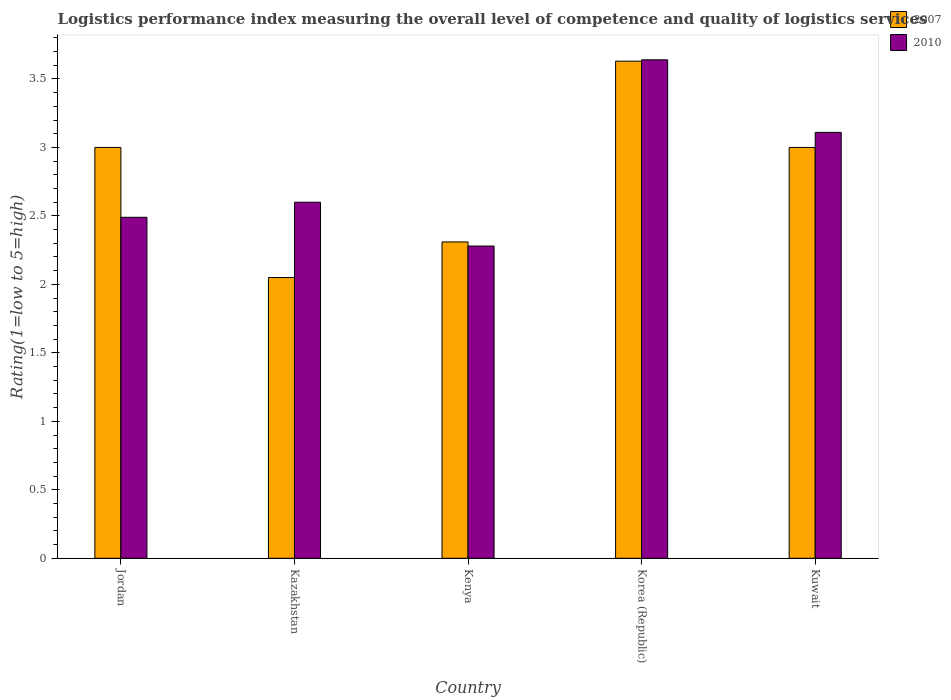How many groups of bars are there?
Make the answer very short. 5. How many bars are there on the 3rd tick from the right?
Keep it short and to the point. 2. What is the label of the 2nd group of bars from the left?
Make the answer very short. Kazakhstan. In how many cases, is the number of bars for a given country not equal to the number of legend labels?
Keep it short and to the point. 0. What is the Logistic performance index in 2010 in Kenya?
Your answer should be compact. 2.28. Across all countries, what is the maximum Logistic performance index in 2007?
Provide a succinct answer. 3.63. Across all countries, what is the minimum Logistic performance index in 2010?
Provide a short and direct response. 2.28. In which country was the Logistic performance index in 2010 minimum?
Ensure brevity in your answer.  Kenya. What is the total Logistic performance index in 2010 in the graph?
Your response must be concise. 14.12. What is the difference between the Logistic performance index in 2010 in Jordan and that in Korea (Republic)?
Your answer should be compact. -1.15. What is the difference between the Logistic performance index in 2007 in Korea (Republic) and the Logistic performance index in 2010 in Kenya?
Your response must be concise. 1.35. What is the average Logistic performance index in 2007 per country?
Your response must be concise. 2.8. What is the difference between the Logistic performance index of/in 2007 and Logistic performance index of/in 2010 in Kenya?
Your answer should be compact. 0.03. What is the ratio of the Logistic performance index in 2007 in Jordan to that in Kazakhstan?
Offer a terse response. 1.46. Is the difference between the Logistic performance index in 2007 in Korea (Republic) and Kuwait greater than the difference between the Logistic performance index in 2010 in Korea (Republic) and Kuwait?
Your response must be concise. Yes. What is the difference between the highest and the second highest Logistic performance index in 2007?
Provide a short and direct response. -0.63. What is the difference between the highest and the lowest Logistic performance index in 2007?
Ensure brevity in your answer.  1.58. Is the sum of the Logistic performance index in 2007 in Kazakhstan and Kuwait greater than the maximum Logistic performance index in 2010 across all countries?
Ensure brevity in your answer.  Yes. What does the 1st bar from the right in Kuwait represents?
Your response must be concise. 2010. How many bars are there?
Make the answer very short. 10. How many countries are there in the graph?
Provide a succinct answer. 5. Does the graph contain any zero values?
Give a very brief answer. No. Does the graph contain grids?
Your answer should be compact. No. Where does the legend appear in the graph?
Provide a short and direct response. Top right. How many legend labels are there?
Ensure brevity in your answer.  2. What is the title of the graph?
Keep it short and to the point. Logistics performance index measuring the overall level of competence and quality of logistics services. What is the label or title of the Y-axis?
Give a very brief answer. Rating(1=low to 5=high). What is the Rating(1=low to 5=high) of 2010 in Jordan?
Your response must be concise. 2.49. What is the Rating(1=low to 5=high) of 2007 in Kazakhstan?
Offer a very short reply. 2.05. What is the Rating(1=low to 5=high) in 2010 in Kazakhstan?
Keep it short and to the point. 2.6. What is the Rating(1=low to 5=high) in 2007 in Kenya?
Provide a short and direct response. 2.31. What is the Rating(1=low to 5=high) in 2010 in Kenya?
Keep it short and to the point. 2.28. What is the Rating(1=low to 5=high) of 2007 in Korea (Republic)?
Ensure brevity in your answer.  3.63. What is the Rating(1=low to 5=high) of 2010 in Korea (Republic)?
Offer a terse response. 3.64. What is the Rating(1=low to 5=high) of 2010 in Kuwait?
Give a very brief answer. 3.11. Across all countries, what is the maximum Rating(1=low to 5=high) in 2007?
Provide a short and direct response. 3.63. Across all countries, what is the maximum Rating(1=low to 5=high) of 2010?
Provide a short and direct response. 3.64. Across all countries, what is the minimum Rating(1=low to 5=high) in 2007?
Ensure brevity in your answer.  2.05. Across all countries, what is the minimum Rating(1=low to 5=high) in 2010?
Your answer should be very brief. 2.28. What is the total Rating(1=low to 5=high) in 2007 in the graph?
Ensure brevity in your answer.  13.99. What is the total Rating(1=low to 5=high) of 2010 in the graph?
Your answer should be compact. 14.12. What is the difference between the Rating(1=low to 5=high) of 2010 in Jordan and that in Kazakhstan?
Keep it short and to the point. -0.11. What is the difference between the Rating(1=low to 5=high) of 2007 in Jordan and that in Kenya?
Offer a very short reply. 0.69. What is the difference between the Rating(1=low to 5=high) in 2010 in Jordan and that in Kenya?
Offer a very short reply. 0.21. What is the difference between the Rating(1=low to 5=high) in 2007 in Jordan and that in Korea (Republic)?
Offer a very short reply. -0.63. What is the difference between the Rating(1=low to 5=high) in 2010 in Jordan and that in Korea (Republic)?
Your answer should be very brief. -1.15. What is the difference between the Rating(1=low to 5=high) of 2007 in Jordan and that in Kuwait?
Make the answer very short. 0. What is the difference between the Rating(1=low to 5=high) of 2010 in Jordan and that in Kuwait?
Your answer should be very brief. -0.62. What is the difference between the Rating(1=low to 5=high) in 2007 in Kazakhstan and that in Kenya?
Make the answer very short. -0.26. What is the difference between the Rating(1=low to 5=high) of 2010 in Kazakhstan and that in Kenya?
Provide a short and direct response. 0.32. What is the difference between the Rating(1=low to 5=high) in 2007 in Kazakhstan and that in Korea (Republic)?
Your response must be concise. -1.58. What is the difference between the Rating(1=low to 5=high) of 2010 in Kazakhstan and that in Korea (Republic)?
Make the answer very short. -1.04. What is the difference between the Rating(1=low to 5=high) of 2007 in Kazakhstan and that in Kuwait?
Your answer should be compact. -0.95. What is the difference between the Rating(1=low to 5=high) of 2010 in Kazakhstan and that in Kuwait?
Keep it short and to the point. -0.51. What is the difference between the Rating(1=low to 5=high) in 2007 in Kenya and that in Korea (Republic)?
Your answer should be very brief. -1.32. What is the difference between the Rating(1=low to 5=high) in 2010 in Kenya and that in Korea (Republic)?
Your answer should be very brief. -1.36. What is the difference between the Rating(1=low to 5=high) in 2007 in Kenya and that in Kuwait?
Keep it short and to the point. -0.69. What is the difference between the Rating(1=low to 5=high) in 2010 in Kenya and that in Kuwait?
Your answer should be very brief. -0.83. What is the difference between the Rating(1=low to 5=high) of 2007 in Korea (Republic) and that in Kuwait?
Ensure brevity in your answer.  0.63. What is the difference between the Rating(1=low to 5=high) in 2010 in Korea (Republic) and that in Kuwait?
Your answer should be compact. 0.53. What is the difference between the Rating(1=low to 5=high) of 2007 in Jordan and the Rating(1=low to 5=high) of 2010 in Kazakhstan?
Give a very brief answer. 0.4. What is the difference between the Rating(1=low to 5=high) in 2007 in Jordan and the Rating(1=low to 5=high) in 2010 in Kenya?
Provide a succinct answer. 0.72. What is the difference between the Rating(1=low to 5=high) in 2007 in Jordan and the Rating(1=low to 5=high) in 2010 in Korea (Republic)?
Your answer should be compact. -0.64. What is the difference between the Rating(1=low to 5=high) in 2007 in Jordan and the Rating(1=low to 5=high) in 2010 in Kuwait?
Provide a succinct answer. -0.11. What is the difference between the Rating(1=low to 5=high) in 2007 in Kazakhstan and the Rating(1=low to 5=high) in 2010 in Kenya?
Keep it short and to the point. -0.23. What is the difference between the Rating(1=low to 5=high) of 2007 in Kazakhstan and the Rating(1=low to 5=high) of 2010 in Korea (Republic)?
Make the answer very short. -1.59. What is the difference between the Rating(1=low to 5=high) of 2007 in Kazakhstan and the Rating(1=low to 5=high) of 2010 in Kuwait?
Ensure brevity in your answer.  -1.06. What is the difference between the Rating(1=low to 5=high) of 2007 in Kenya and the Rating(1=low to 5=high) of 2010 in Korea (Republic)?
Offer a terse response. -1.33. What is the difference between the Rating(1=low to 5=high) of 2007 in Korea (Republic) and the Rating(1=low to 5=high) of 2010 in Kuwait?
Your answer should be compact. 0.52. What is the average Rating(1=low to 5=high) in 2007 per country?
Make the answer very short. 2.8. What is the average Rating(1=low to 5=high) of 2010 per country?
Provide a short and direct response. 2.82. What is the difference between the Rating(1=low to 5=high) in 2007 and Rating(1=low to 5=high) in 2010 in Jordan?
Provide a succinct answer. 0.51. What is the difference between the Rating(1=low to 5=high) in 2007 and Rating(1=low to 5=high) in 2010 in Kazakhstan?
Ensure brevity in your answer.  -0.55. What is the difference between the Rating(1=low to 5=high) in 2007 and Rating(1=low to 5=high) in 2010 in Kenya?
Your answer should be very brief. 0.03. What is the difference between the Rating(1=low to 5=high) in 2007 and Rating(1=low to 5=high) in 2010 in Korea (Republic)?
Provide a short and direct response. -0.01. What is the difference between the Rating(1=low to 5=high) of 2007 and Rating(1=low to 5=high) of 2010 in Kuwait?
Your answer should be compact. -0.11. What is the ratio of the Rating(1=low to 5=high) of 2007 in Jordan to that in Kazakhstan?
Your response must be concise. 1.46. What is the ratio of the Rating(1=low to 5=high) of 2010 in Jordan to that in Kazakhstan?
Offer a terse response. 0.96. What is the ratio of the Rating(1=low to 5=high) of 2007 in Jordan to that in Kenya?
Your answer should be very brief. 1.3. What is the ratio of the Rating(1=low to 5=high) in 2010 in Jordan to that in Kenya?
Give a very brief answer. 1.09. What is the ratio of the Rating(1=low to 5=high) in 2007 in Jordan to that in Korea (Republic)?
Ensure brevity in your answer.  0.83. What is the ratio of the Rating(1=low to 5=high) of 2010 in Jordan to that in Korea (Republic)?
Your answer should be very brief. 0.68. What is the ratio of the Rating(1=low to 5=high) of 2007 in Jordan to that in Kuwait?
Offer a terse response. 1. What is the ratio of the Rating(1=low to 5=high) in 2010 in Jordan to that in Kuwait?
Offer a terse response. 0.8. What is the ratio of the Rating(1=low to 5=high) of 2007 in Kazakhstan to that in Kenya?
Provide a short and direct response. 0.89. What is the ratio of the Rating(1=low to 5=high) of 2010 in Kazakhstan to that in Kenya?
Your answer should be compact. 1.14. What is the ratio of the Rating(1=low to 5=high) in 2007 in Kazakhstan to that in Korea (Republic)?
Your response must be concise. 0.56. What is the ratio of the Rating(1=low to 5=high) in 2010 in Kazakhstan to that in Korea (Republic)?
Your answer should be compact. 0.71. What is the ratio of the Rating(1=low to 5=high) of 2007 in Kazakhstan to that in Kuwait?
Make the answer very short. 0.68. What is the ratio of the Rating(1=low to 5=high) in 2010 in Kazakhstan to that in Kuwait?
Your response must be concise. 0.84. What is the ratio of the Rating(1=low to 5=high) in 2007 in Kenya to that in Korea (Republic)?
Give a very brief answer. 0.64. What is the ratio of the Rating(1=low to 5=high) of 2010 in Kenya to that in Korea (Republic)?
Ensure brevity in your answer.  0.63. What is the ratio of the Rating(1=low to 5=high) of 2007 in Kenya to that in Kuwait?
Offer a terse response. 0.77. What is the ratio of the Rating(1=low to 5=high) of 2010 in Kenya to that in Kuwait?
Offer a very short reply. 0.73. What is the ratio of the Rating(1=low to 5=high) of 2007 in Korea (Republic) to that in Kuwait?
Provide a succinct answer. 1.21. What is the ratio of the Rating(1=low to 5=high) in 2010 in Korea (Republic) to that in Kuwait?
Keep it short and to the point. 1.17. What is the difference between the highest and the second highest Rating(1=low to 5=high) of 2007?
Your answer should be very brief. 0.63. What is the difference between the highest and the second highest Rating(1=low to 5=high) in 2010?
Your answer should be compact. 0.53. What is the difference between the highest and the lowest Rating(1=low to 5=high) in 2007?
Provide a short and direct response. 1.58. What is the difference between the highest and the lowest Rating(1=low to 5=high) in 2010?
Provide a succinct answer. 1.36. 